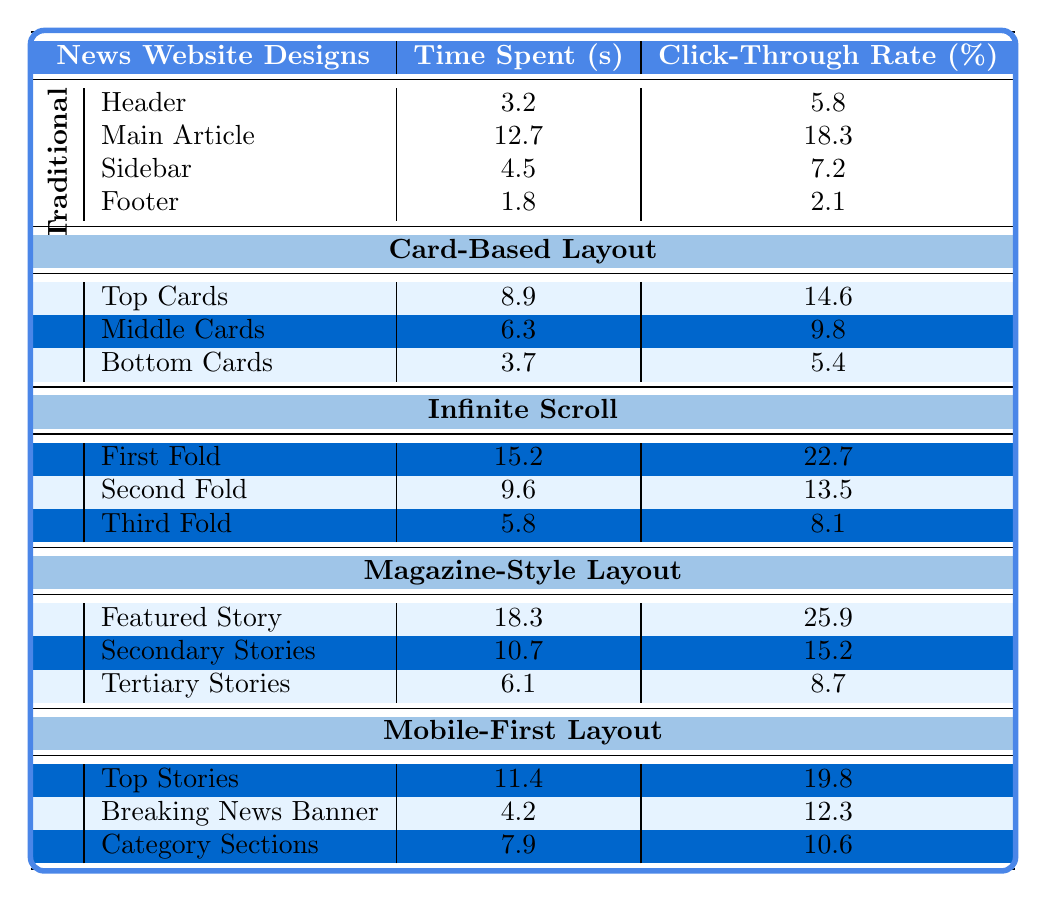What is the click-through rate for the Main Article in the Traditional Layout? The click-through rate is provided in the table under the Traditional Layout for the Main Article area, where it indicates 18.3%.
Answer: 18.3% Which design has the highest time spent on a single area? The table shows that the Magazine-Style Layout has the highest time spent on the Featured Story, with 18.3 seconds, compared to other areas across all designs.
Answer: Magazine-Style Layout What is the average time spent across all areas in the Card-Based Layout? The total time spent in the Card-Based Layout is 8.9 seconds (Top Cards) + 6.3 seconds (Middle Cards) + 3.7 seconds (Bottom Cards) = 18.9 seconds. Dividing this by the 3 areas gives an average of 18.9/3 = 6.3 seconds.
Answer: 6.3 seconds Which layout has the lowest click-through rate for any area? Reviewing the click-through rates, the lowest recorded is 2.1% in the Footer of the Traditional Layout, which is lower than any other areas in all designs.
Answer: Traditional Layout What is the difference in click-through rates between the Featured Story and the Main Article? The click-through rate for the Featured Story is 25.9% and for the Main Article it is 18.3%. The difference is calculated by subtracting 18.3 from 25.9, which gives 7.6%.
Answer: 7.6% True or False: The Infinite Scroll layout has a higher click-through rate than the Card-Based layout for the Bottom Cards area. The Infinite Scroll's Third Fold click-through rate is 8.1%, while the Card-Based's Bottom Cards rate is 5.4%. Since 8.1% is greater than 5.4%, the statement is true.
Answer: True What is the total time spent across all designs for the Sidebar area? In the table, only the Traditional layout has a Sidebar area with a time spent of 4.5 seconds; thus the total for all designs in that area is simply this value.
Answer: 4.5 seconds Calculate the average click-through rate for the Mobile-First Layout. The click-through rates for the Mobile-First Layout are 19.8% (Top Stories), 12.3% (Breaking News Banner), and 10.6% (Category Sections). Summing these gives 19.8 + 12.3 + 10.6 = 42.7%, which when divided by 3 (the number of areas) gives an average of 14.23%.
Answer: 14.23% Which layout had the least amount of time spent on any area? The Footer area of the Traditional Layout shows the least time spent at 1.8 seconds, which is less than any other recorded times in all layouts' areas.
Answer: Traditional Layout What is the total click-through rate for the First Fold and Second Fold in the Infinite Scroll? The click-through rates are 22.7% for the First Fold and 13.5% for the Second Fold. Adding these rates gives 22.7 + 13.5 = 36.2%.
Answer: 36.2% Does the Card-Based Layout have an area with a click-through rate over 15%? The highest click-through rate for Card-Based Layout is 14.6% for the Top Cards, which is less than 15%, thus no area meets the criteria.
Answer: No 